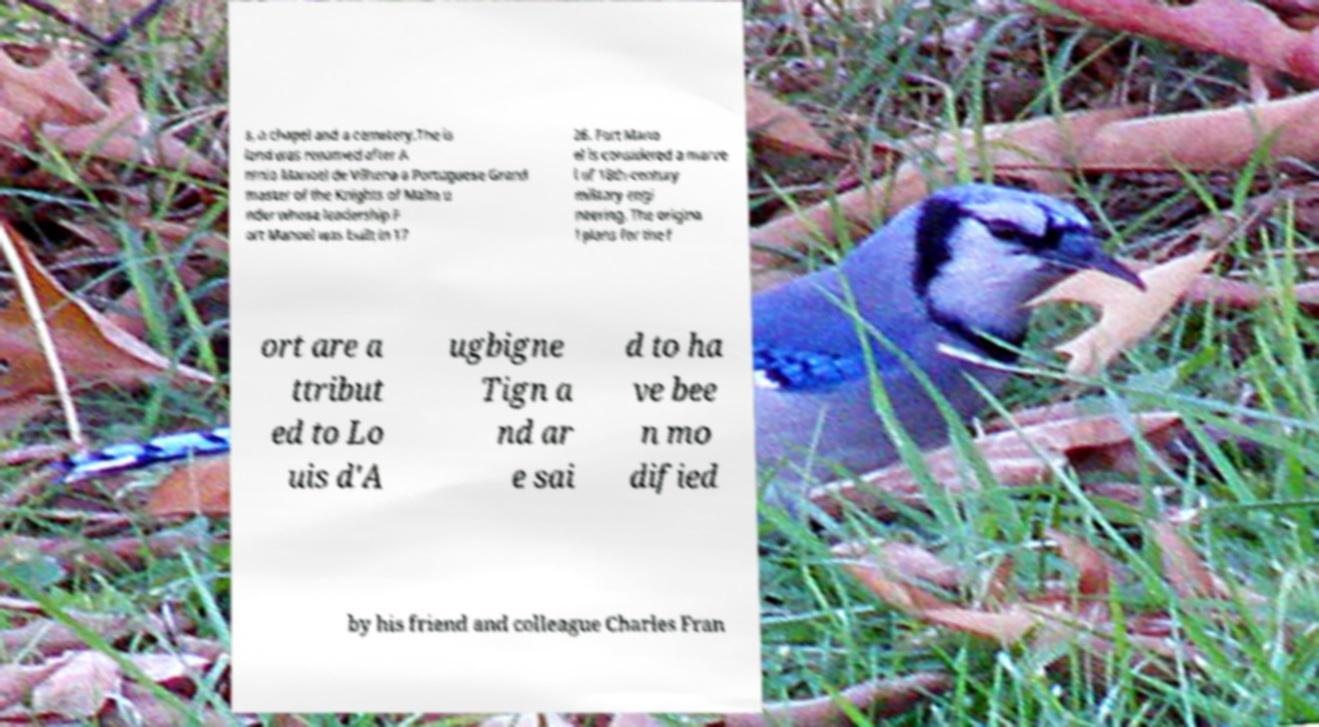I need the written content from this picture converted into text. Can you do that? s, a chapel and a cemetery.The is land was renamed after A ntnio Manoel de Vilhena a Portuguese Grand master of the Knights of Malta u nder whose leadership F ort Manoel was built in 17 26. Fort Mano el is considered a marve l of 18th-century military engi neering. The origina l plans for the f ort are a ttribut ed to Lo uis d'A ugbigne Tign a nd ar e sai d to ha ve bee n mo dified by his friend and colleague Charles Fran 